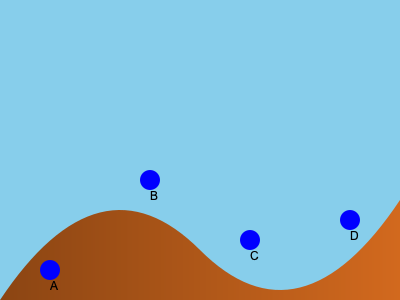Based on the topographical map showing potential wind turbine locations (A, B, C, and D), which site would likely yield the highest wind energy output? To determine the optimal wind turbine placement, we need to consider several factors:

1. Elevation: Higher elevations generally have stronger and more consistent wind speeds.
2. Topography: Ridge lines and hill tops tend to have better wind conditions due to the wind speed-up effect.
3. Exposure: Areas with minimal obstruction from surrounding terrain will have better wind access.

Analyzing the given locations:

A: Located at a low elevation with potential obstruction from nearby hills.
B: Positioned at the highest point on a ridge, offering maximum exposure and elevation.
C: Situated on a slope, but not at the peak, with some exposure.
D: Located on a relatively high point, but not as exposed as B.

The wind speed at these locations can be estimated using the wind profile power law:

$$ v = v_r \left(\frac{h}{h_r}\right)^\alpha $$

Where:
$v$ = wind speed at height $h$
$v_r$ = known wind speed at reference height $h_r$
$\alpha$ = wind shear exponent (typically 0.1-0.4)

Location B, being at the highest elevation and on a ridge line, would likely have the highest wind speed according to this formula. It also benefits from the speed-up effect of wind flowing over a ridge.

Therefore, location B would likely yield the highest wind energy output due to its optimal combination of elevation, topography, and exposure.
Answer: B 